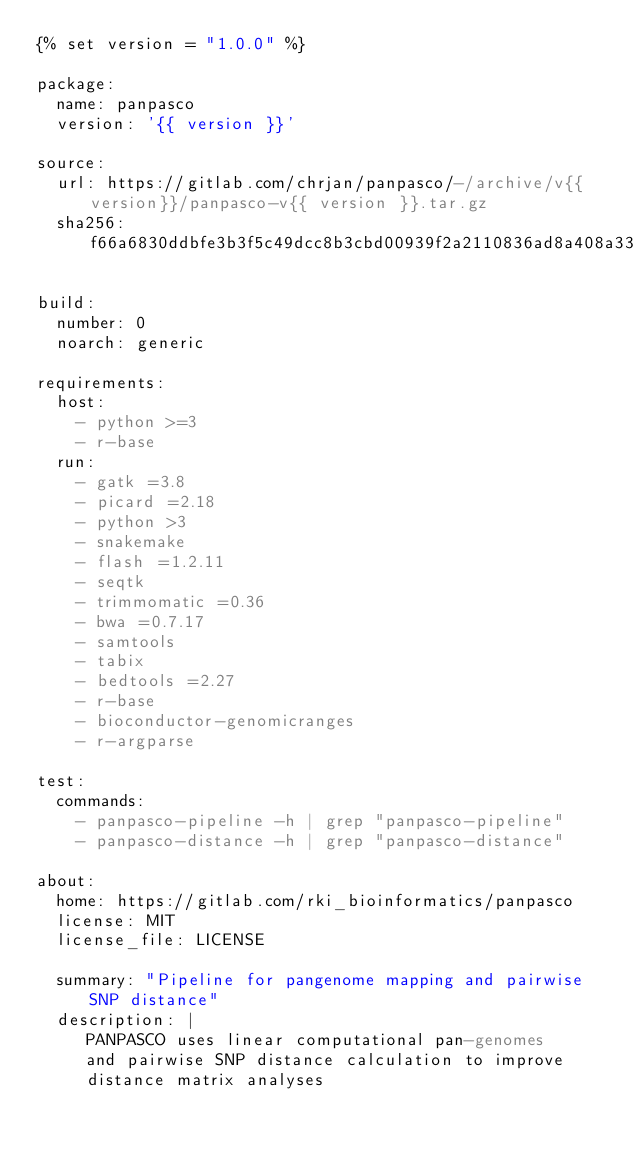Convert code to text. <code><loc_0><loc_0><loc_500><loc_500><_YAML_>{% set version = "1.0.0" %}

package:
  name: panpasco
  version: '{{ version }}'

source:
  url: https://gitlab.com/chrjan/panpasco/-/archive/v{{version}}/panpasco-v{{ version }}.tar.gz
  sha256: f66a6830ddbfe3b3f5c49dcc8b3cbd00939f2a2110836ad8a408a33765d454e8

build:
  number: 0
  noarch: generic
  
requirements:
  host: 
    - python >=3
    - r-base 
  run:
    - gatk =3.8
    - picard =2.18
    - python >3
    - snakemake
    - flash =1.2.11
    - seqtk
    - trimmomatic =0.36
    - bwa =0.7.17
    - samtools
    - tabix
    - bedtools =2.27
    - r-base
    - bioconductor-genomicranges
    - r-argparse 

test:
  commands:
    - panpasco-pipeline -h | grep "panpasco-pipeline" 
    - panpasco-distance -h | grep "panpasco-distance"

about:
  home: https://gitlab.com/rki_bioinformatics/panpasco
  license: MIT
  license_file: LICENSE

  summary: "Pipeline for pangenome mapping and pairwise SNP distance"
  description: |
     PANPASCO uses linear computational pan-genomes 
     and pairwise SNP distance calculation to improve
     distance matrix analyses
</code> 